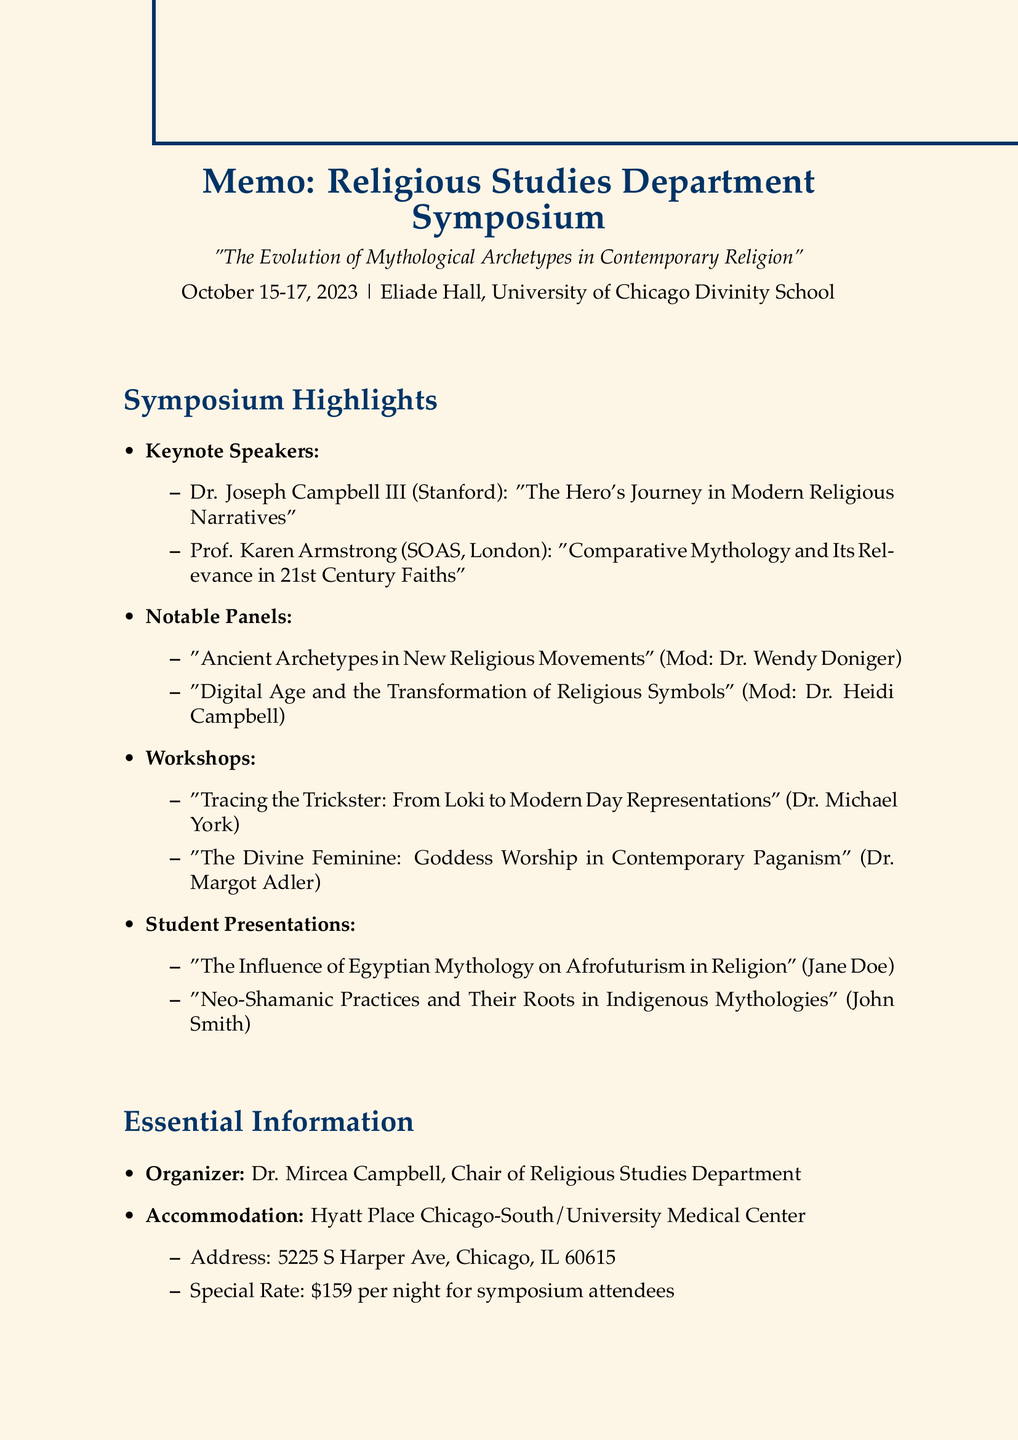what are the dates of the symposium? The symposium takes place from October 15 to October 17, 2023.
Answer: October 15-17, 2023 who is the organizer of the symposium? The organizer listed in the document is Dr. Mircea Campbell.
Answer: Dr. Mircea Campbell what is the venue for the event? The venue for the symposium is Eliade Hall at the University of Chicago Divinity School.
Answer: Eliade Hall, University of Chicago Divinity School who is facilitating the workshop on Goddess Worship? The document identifies Dr. Margot Adler as the facilitator for this workshop.
Answer: Dr. Margot Adler what is one of the student presentations about? The student presentation topics listed include Egyptian mythology's influence on Afrofuturism.
Answer: The Influence of Egyptian Mythology on Afrofuturism in Religion how many keynote speakers are mentioned? There are two keynote speakers mentioned in the document.
Answer: Two what is the address of the recommended hotel? The recommended hotel address is provided in the document as 5225 S Harper Ave, Chicago, IL 60615.
Answer: 5225 S Harper Ave, Chicago, IL 60615 who is presenting on Neo-Shamanic Practices? The document states that John Smith is presenting on this topic.
Answer: John Smith what is the special rate for symposium attendees at the hotel? The special rate for symposium attendees at the hotel is stated as $159 per night.
Answer: $159 per night 